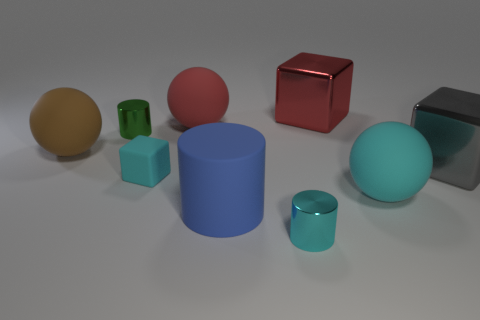Add 1 tiny cyan cylinders. How many objects exist? 10 Subtract all cylinders. How many objects are left? 6 Add 6 big cyan shiny balls. How many big cyan shiny balls exist? 6 Subtract 1 green cylinders. How many objects are left? 8 Subtract all big purple metal cubes. Subtract all big cyan spheres. How many objects are left? 8 Add 4 brown rubber things. How many brown rubber things are left? 5 